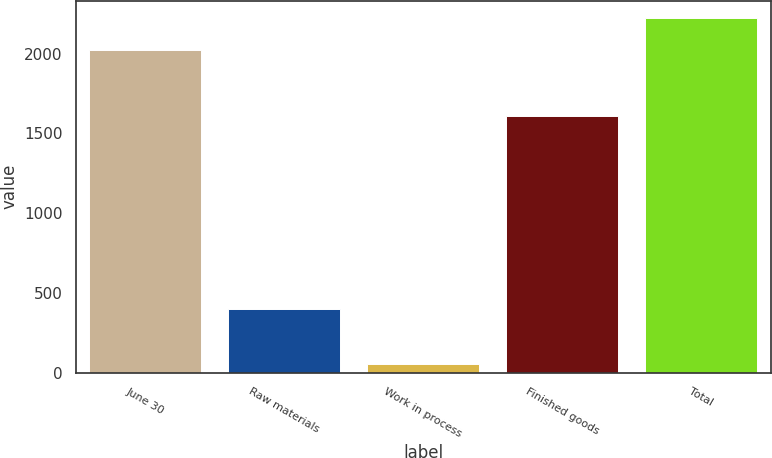Convert chart. <chart><loc_0><loc_0><loc_500><loc_500><bar_chart><fcel>June 30<fcel>Raw materials<fcel>Work in process<fcel>Finished goods<fcel>Total<nl><fcel>2019<fcel>399<fcel>53<fcel>1611<fcel>2220<nl></chart> 